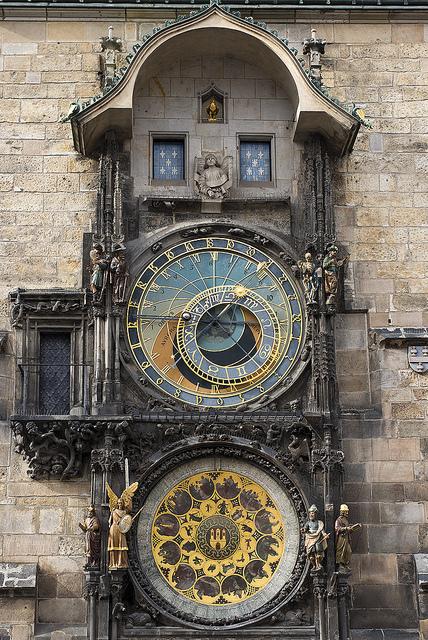What powers these clocks?
Keep it brief. Energy. Is this a digital clock?
Keep it brief. No. What is the statue above the clock?
Short answer required. Angel. Is this a clock?
Short answer required. Yes. How many windows?
Quick response, please. 3. What color is the clock?
Concise answer only. Blue. 